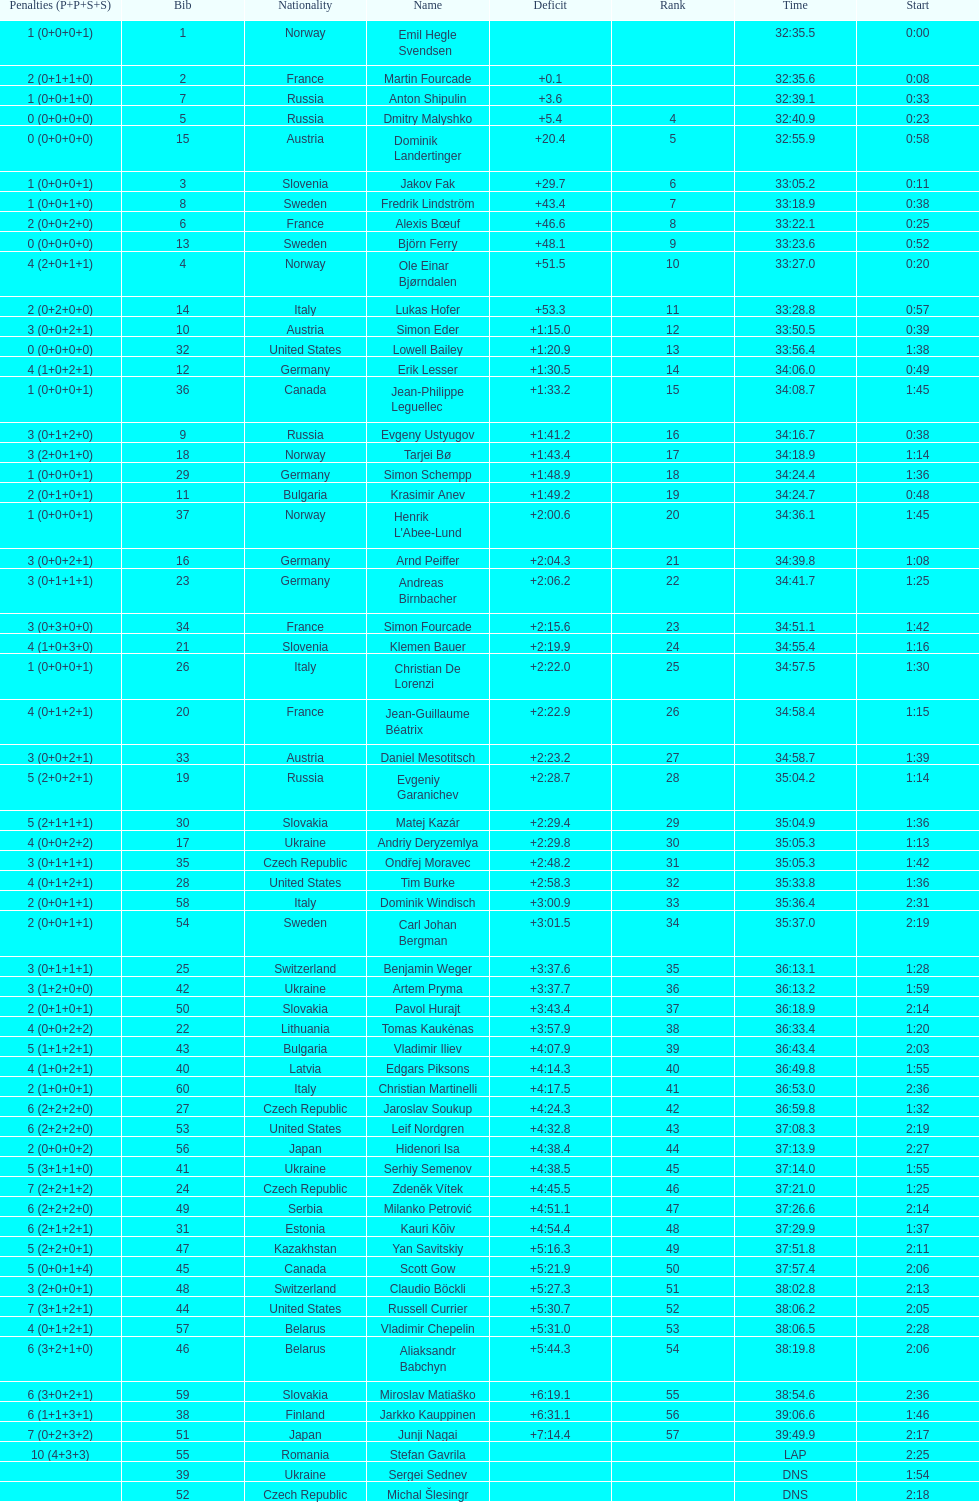What were the total number of "ties" (people who finished with the exact same time?) 2. 